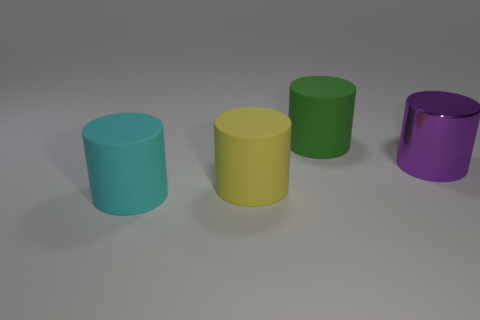Add 2 large brown rubber objects. How many objects exist? 6 Add 4 purple cylinders. How many purple cylinders are left? 5 Add 4 small purple shiny blocks. How many small purple shiny blocks exist? 4 Subtract 0 brown balls. How many objects are left? 4 Subtract all big purple shiny cylinders. Subtract all big gray rubber things. How many objects are left? 3 